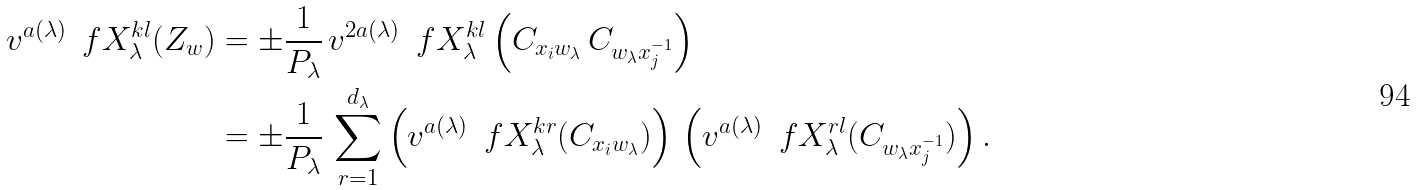<formula> <loc_0><loc_0><loc_500><loc_500>v ^ { a ( \lambda ) } \, \ f X _ { \lambda } ^ { k l } ( Z _ { w } ) & = \pm \frac { 1 } { P _ { \lambda } } \, v ^ { 2 a ( \lambda ) } \, \ f X _ { \lambda } ^ { k l } \left ( C _ { x _ { i } w _ { \lambda } } \, C _ { w _ { \lambda } x _ { j } ^ { - 1 } } \right ) \\ & = \pm \frac { 1 } { P _ { \lambda } } \, \sum _ { r = 1 } ^ { d _ { \lambda } } \left ( v ^ { a ( \lambda ) } \, \ f X _ { \lambda } ^ { k r } ( C _ { x _ { i } w _ { \lambda } } ) \right ) \, \left ( v ^ { a ( \lambda ) } \, \ f X _ { \lambda } ^ { r l } ( C _ { w _ { \lambda } x _ { j } ^ { - 1 } } ) \right ) .</formula> 